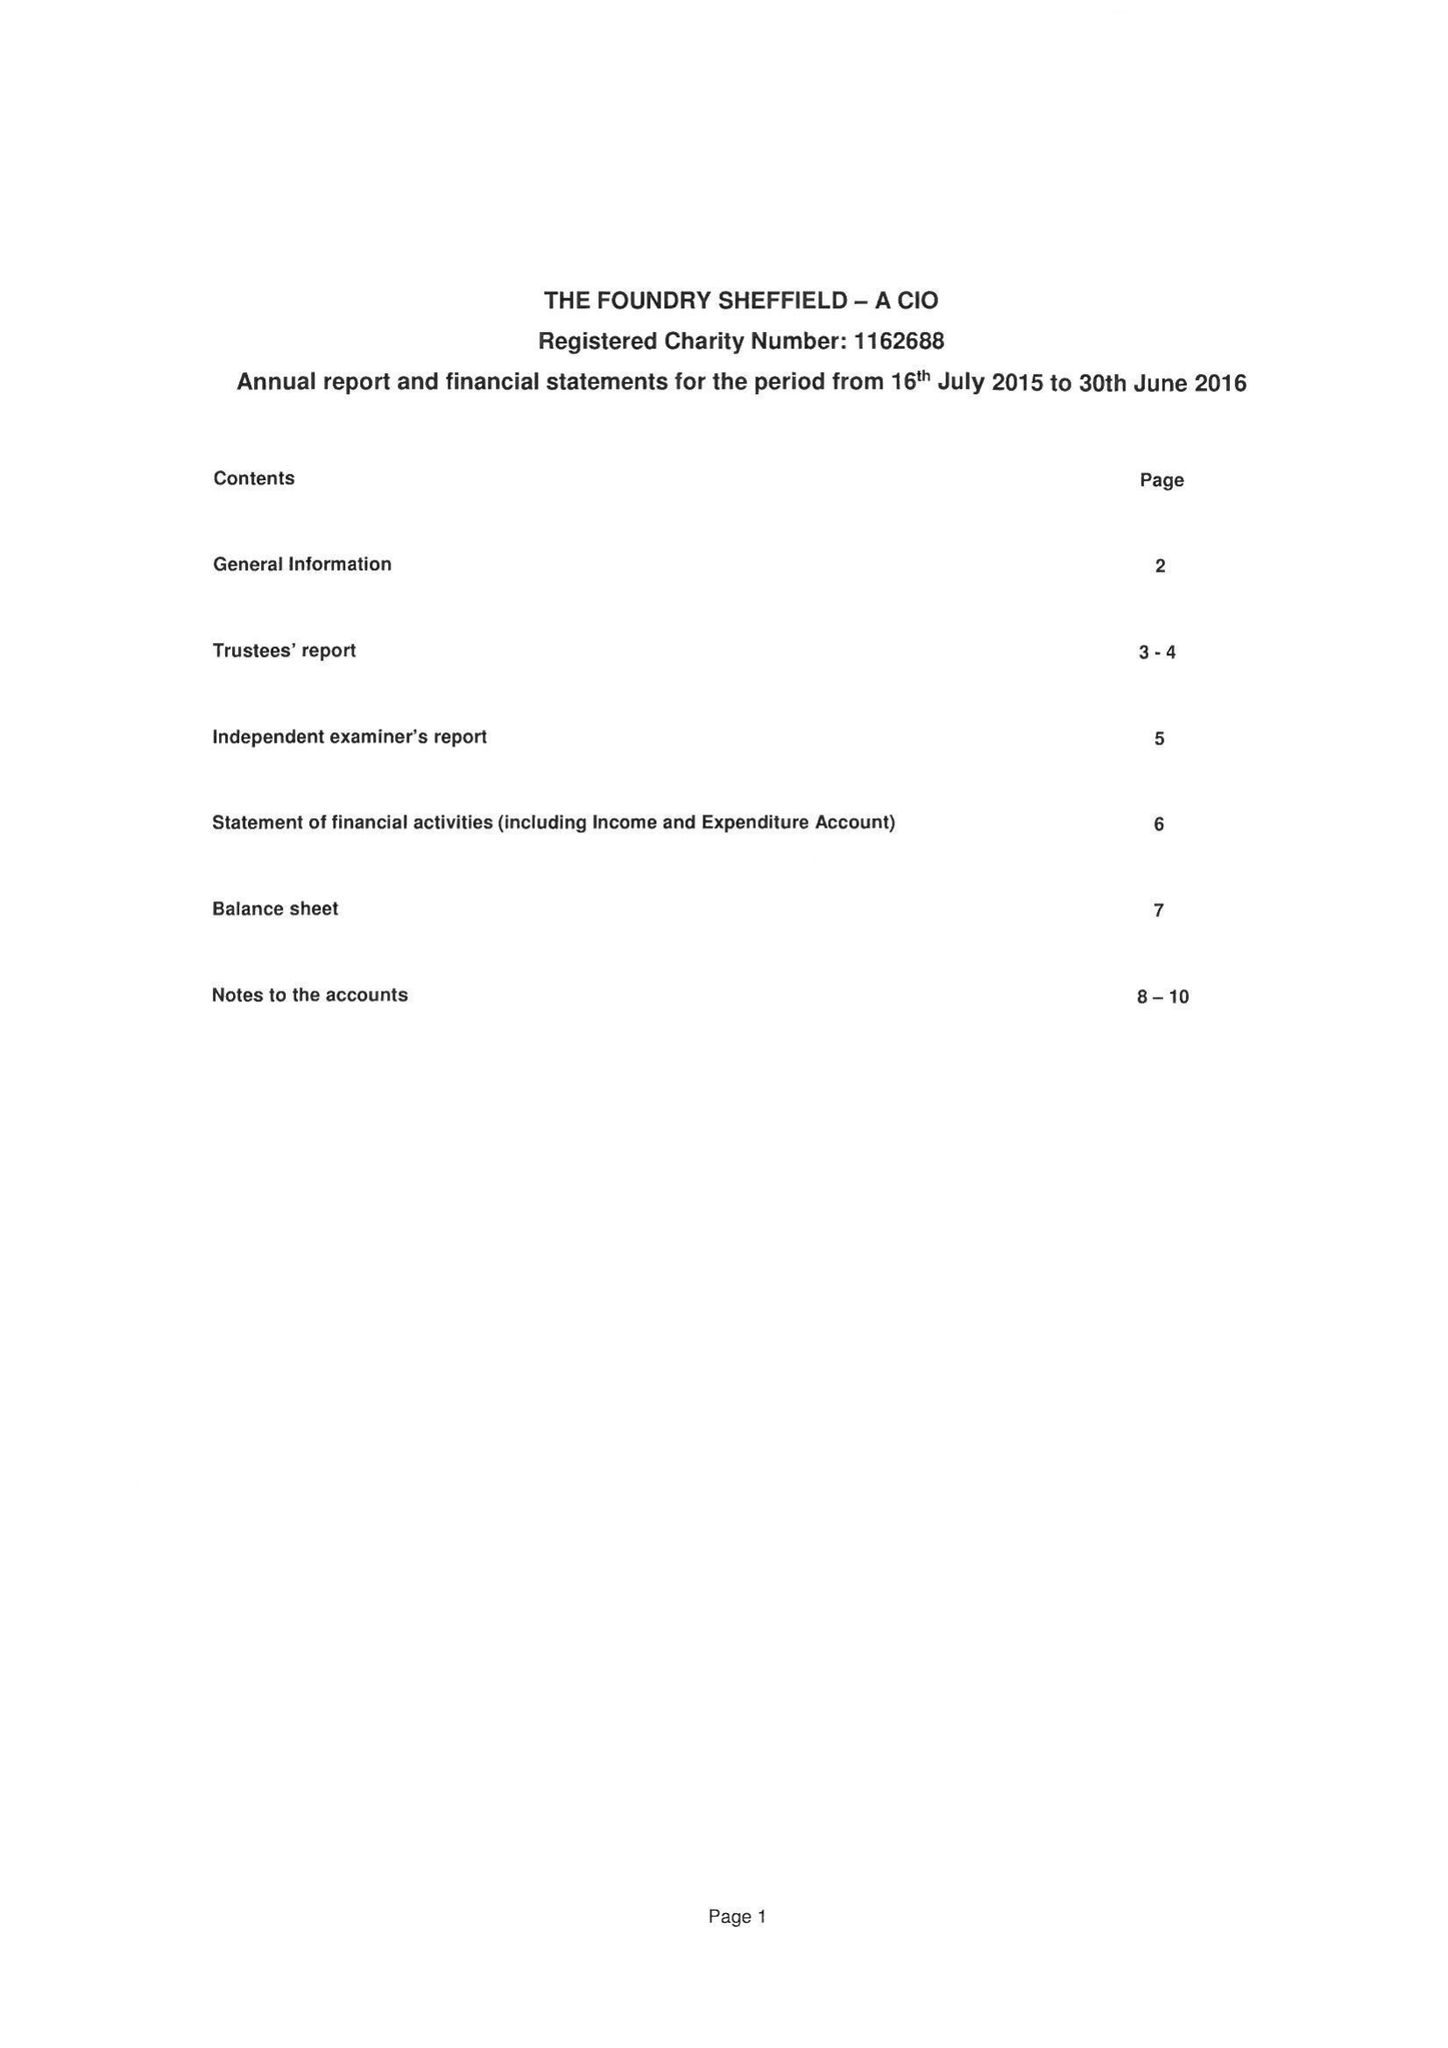What is the value for the address__street_line?
Answer the question using a single word or phrase. NORFOLK STREET 